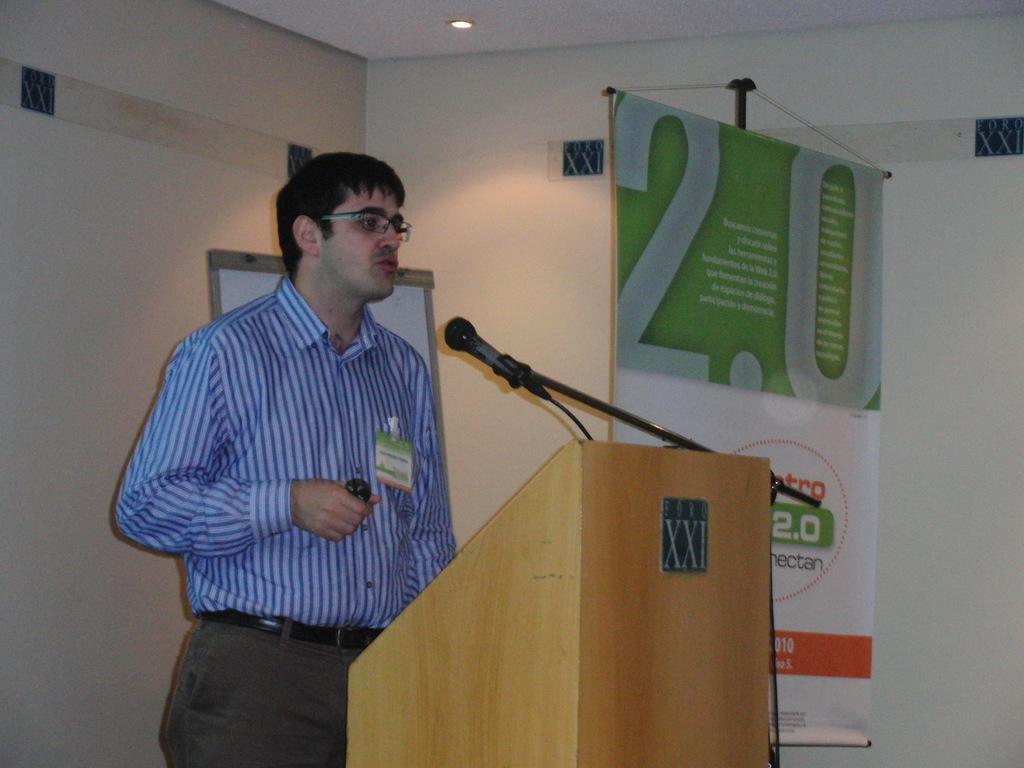Can you describe this image briefly? In this image we can see a man standing holding an object inside a speaker stand. We can also see a mic with a stand, a banner with some text on it, a board, a wall and a roof with a ceiling light. 